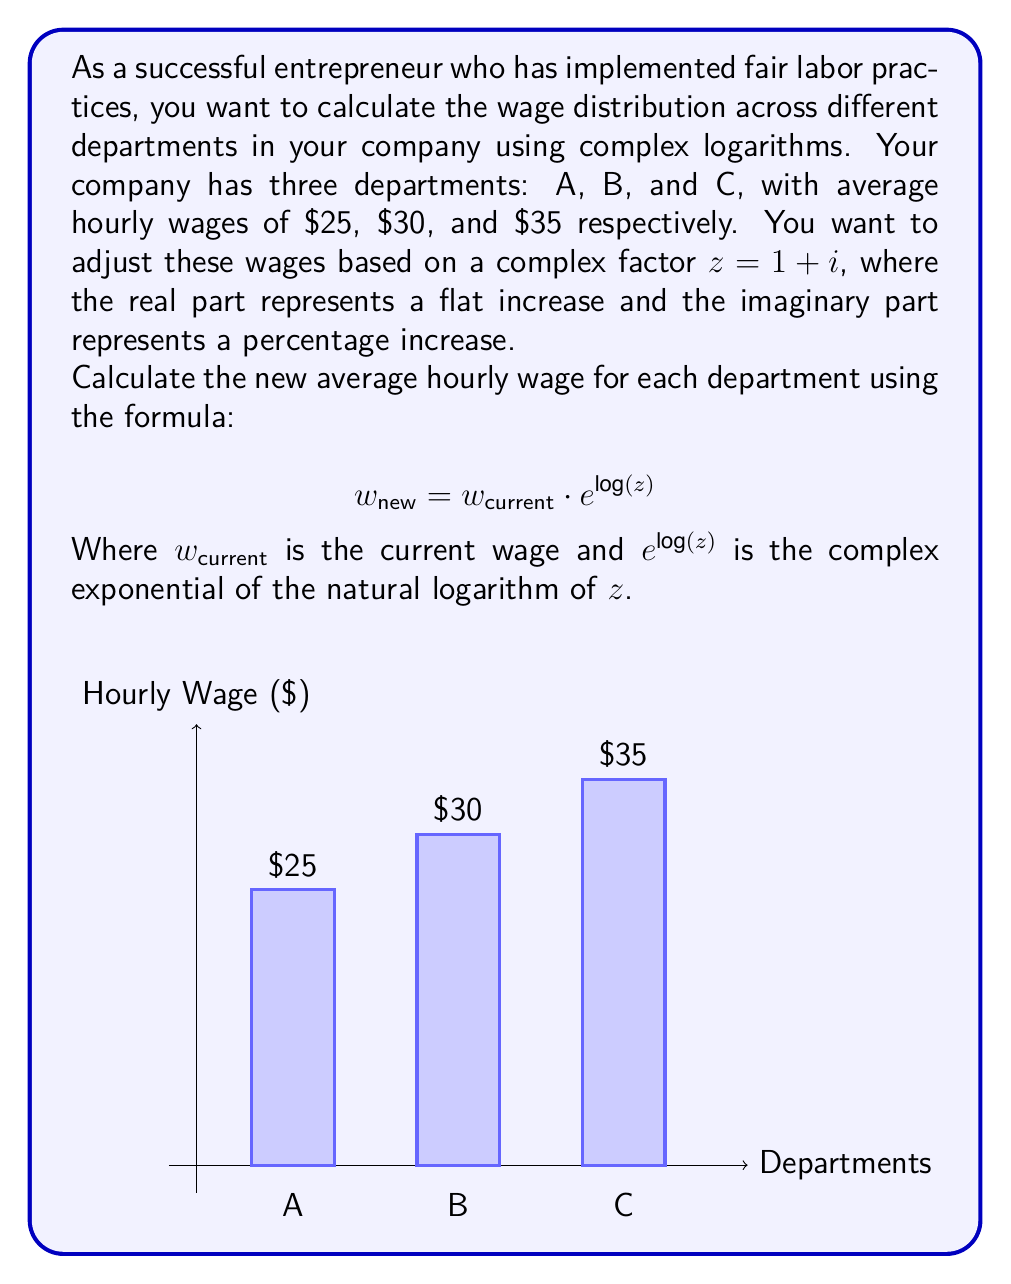Could you help me with this problem? Let's solve this problem step by step:

1) First, we need to calculate $\log(z)$ where $z = 1 + i$:
   
   $$\log(z) = \log(1 + i) = \ln|1 + i| + i\arg(1 + i)$$
   
   $|1 + i| = \sqrt{1^2 + 1^2} = \sqrt{2}$
   $\arg(1 + i) = \tan^{-1}(1/1) = \pi/4$
   
   So, $\log(z) = \ln(\sqrt{2}) + i\pi/4$

2) Now we need to calculate $e^{\log(z)}$:
   
   $$e^{\log(z)} = e^{\ln(\sqrt{2}) + i\pi/4} = e^{\ln(\sqrt{2})} \cdot e^{i\pi/4}$$
   
   $e^{\ln(\sqrt{2})} = \sqrt{2}$
   $e^{i\pi/4} = \cos(\pi/4) + i\sin(\pi/4) = \frac{\sqrt{2}}{2} + i\frac{\sqrt{2}}{2}$
   
   So, $e^{\log(z)} = \sqrt{2} \cdot (\frac{\sqrt{2}}{2} + i\frac{\sqrt{2}}{2}) = 1 + i$

3) Now we can calculate the new wages for each department:

   Department A: $w_{new} = 25 \cdot (1 + i) = 25 + 25i$
   Department B: $w_{new} = 30 \cdot (1 + i) = 30 + 30i$
   Department C: $w_{new} = 35 \cdot (1 + i) = 35 + 35i$

4) To interpret these results:
   - The real part represents the new base wage
   - The imaginary part represents an additional bonus

5) To get the final wage, we take the magnitude of each complex number:

   Department A: $|25 + 25i| = \sqrt{25^2 + 25^2} = 25\sqrt{2} \approx 35.36$
   Department B: $|30 + 30i| = \sqrt{30^2 + 30^2} = 30\sqrt{2} \approx 42.43$
   Department C: $|35 + 35i| = \sqrt{35^2 + 35^2} = 35\sqrt{2} \approx 49.50$
Answer: New hourly wages: A: $35.36, B: $42.43, C: $49.50 (rounded to 2 decimal places) 